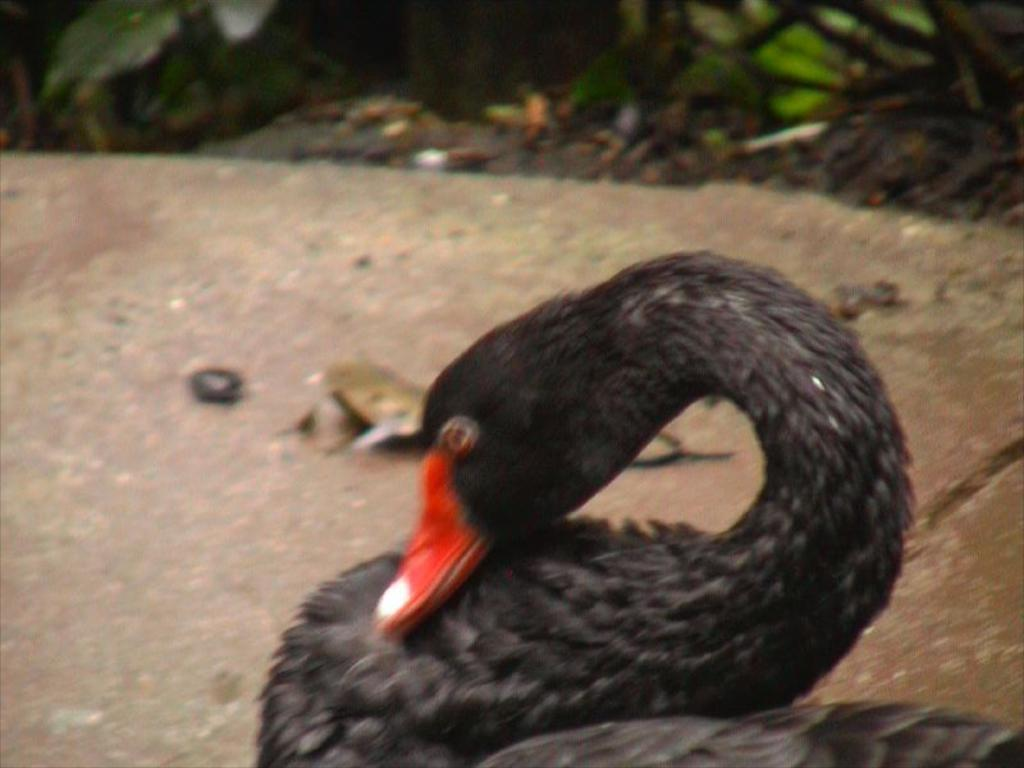What type of animal is in the image? There is a black duck in the image. What is the duck doing in the image? The duck has its head downwards. What can be seen in the background of the image? There are small plants in the background of the image. How many pages does the duck have in the image? There are no pages present in the image, as it features a black duck with its head downwards and small plants in the background. 